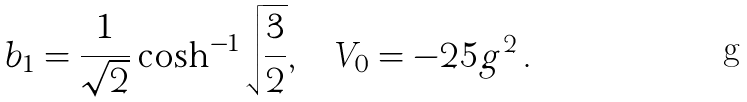Convert formula to latex. <formula><loc_0><loc_0><loc_500><loc_500>b _ { 1 } = \frac { 1 } { \sqrt { 2 } } \cosh ^ { - 1 } \sqrt { \frac { 3 } { 2 } } , \quad V _ { 0 } = - 2 5 g ^ { 2 } \, .</formula> 